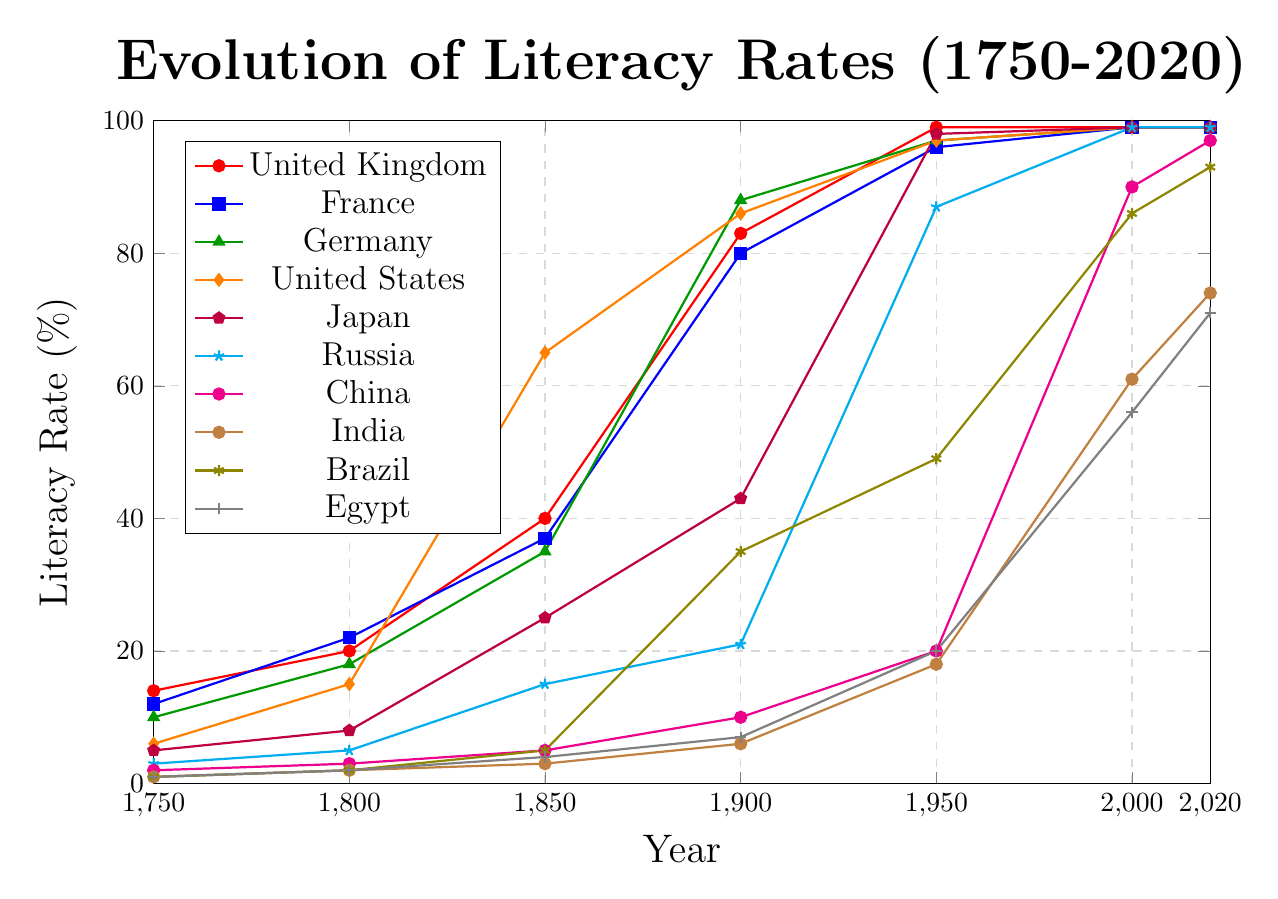What is the trend of literacy rate in Germany from 1750 to 2020? The literacy rate in Germany increases over time, from 10% in 1750 to 99% in 2020, showing a significant rise especially around 1900 when it jumps from 35% to 88%.
Answer: Increasing trend Between 1750 and 2020, which country showed the most dramatic improvement in literacy rate? India showed the most dramatic improvement, starting from 1% in 1750 and reaching 74% in 2020, indicating a 73 percentage point increase.
Answer: India In 1900, which country had the highest literacy rate, and what was it? In 1900, Germany had the highest literacy rate at 88% among the countries compared.
Answer: Germany, 88% Comparing the literacy rate of China and Egypt in 1950, which was higher and by how much? In 1950, China's literacy rate was 20% and Egypt's was 20%, making them equal.
Answer: Equal, 0% Which country reached a literacy rate of 99% first, and in which year did this happen? Japan reached a literacy rate of 99% first, in the year 1950.
Answer: Japan, 1950 How does the literacy rate change in the United States between 1850 and 1900? The literacy rate in the United States increased from 65% in 1850 to 86% in 1900, showing a 21 percentage point increase.
Answer: Increased by 21% Looking at the data for 2000, which three countries share the same literacy rate, and what is that rate? In 2000, the United Kingdom, France, and Germany all have a literacy rate of 99%.
Answer: United Kingdom, France, Germany, 99% What is the average literacy rate of Brazil from 1950 to 2020? To find the average, sum up the literacy rates for Brazil from 1950 to 2020 (49 + 86 + 93) which is 228, and divide by the number of years (3). The average is 228/3 ≈ 76%.
Answer: ≈76% Which country had the lowest literacy rate in 1750 and what was it? In 1750, both India, Brazil, and Egypt had the lowest literacy rate at 1%.
Answer: India, Brazil, Egypt, 1% How much did the literacy rate in Russia increase between 1950 and 2000? The literacy rate in Russia increased from 87% in 1950 to 99% in 2000, indicating a 12 percentage point increase.
Answer: Increased by 12% 